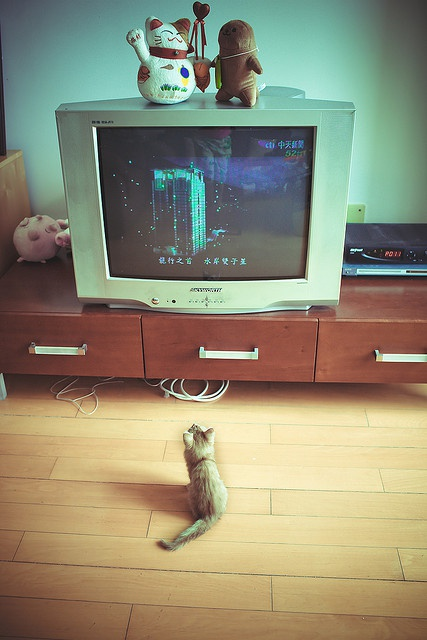Describe the objects in this image and their specific colors. I can see tv in black, gray, aquamarine, and beige tones and cat in black, tan, gray, and khaki tones in this image. 